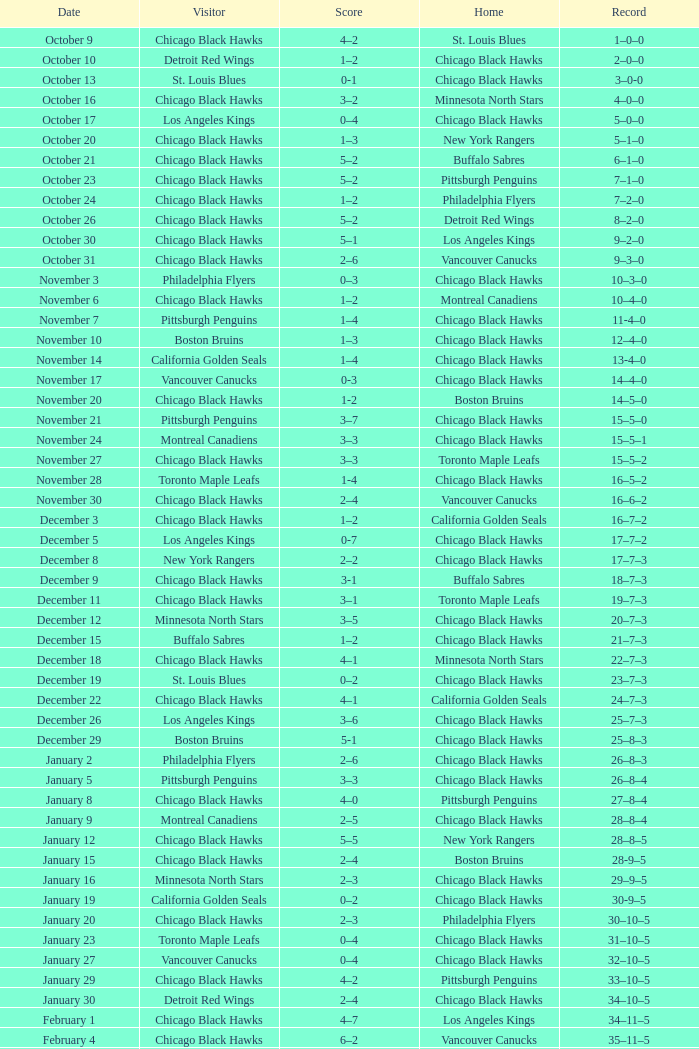What is the Record of the February 26 date? 39–16–7. 